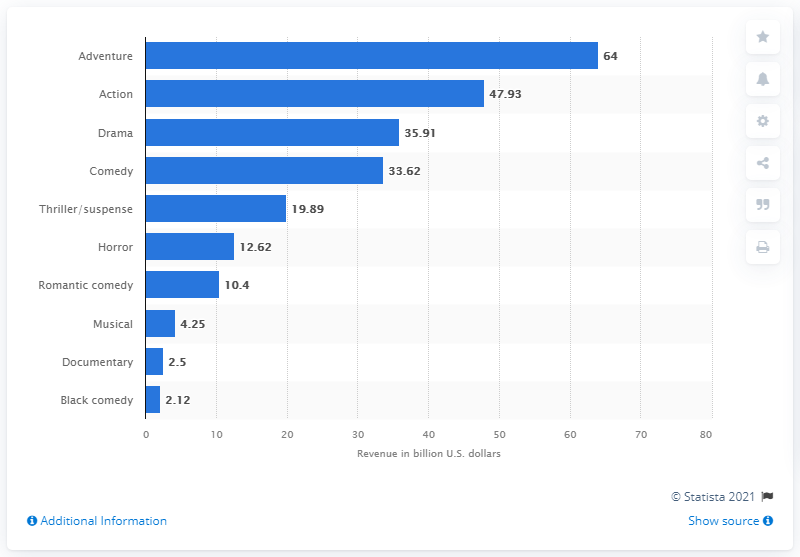Indicate a few pertinent items in this graphic. In 2021, the total box office revenue of adventure movies was $64. The difference between the highest bar and the lowest bar is 61.88... The highest numbered bar is 64. The total revenue of action movies between 1995 and 2021 was 47.93. 